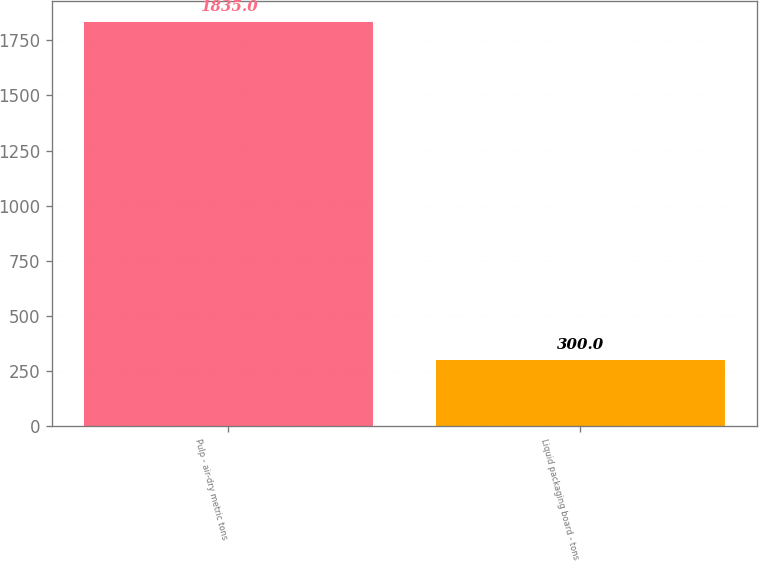<chart> <loc_0><loc_0><loc_500><loc_500><bar_chart><fcel>Pulp - air-dry metric tons<fcel>Liquid packaging board - tons<nl><fcel>1835<fcel>300<nl></chart> 